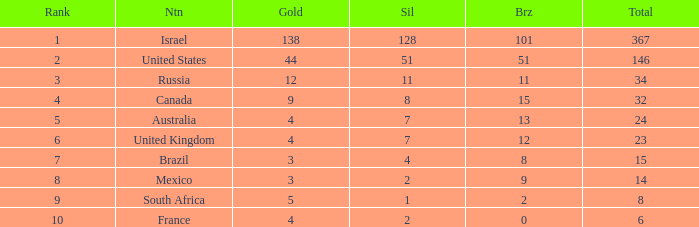What is the maximum number of silvers for a country with fewer than 12 golds and a total less than 8? 2.0. 